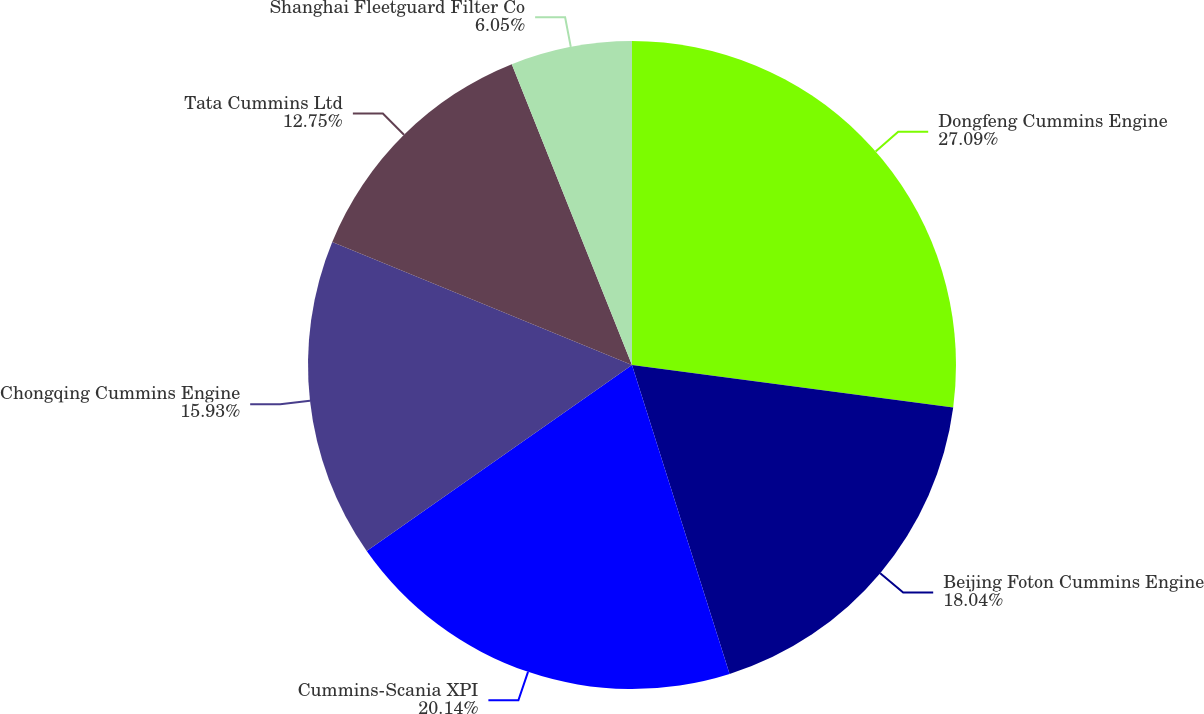Convert chart to OTSL. <chart><loc_0><loc_0><loc_500><loc_500><pie_chart><fcel>Dongfeng Cummins Engine<fcel>Beijing Foton Cummins Engine<fcel>Cummins-Scania XPI<fcel>Chongqing Cummins Engine<fcel>Tata Cummins Ltd<fcel>Shanghai Fleetguard Filter Co<nl><fcel>27.09%<fcel>18.04%<fcel>20.14%<fcel>15.93%<fcel>12.75%<fcel>6.05%<nl></chart> 